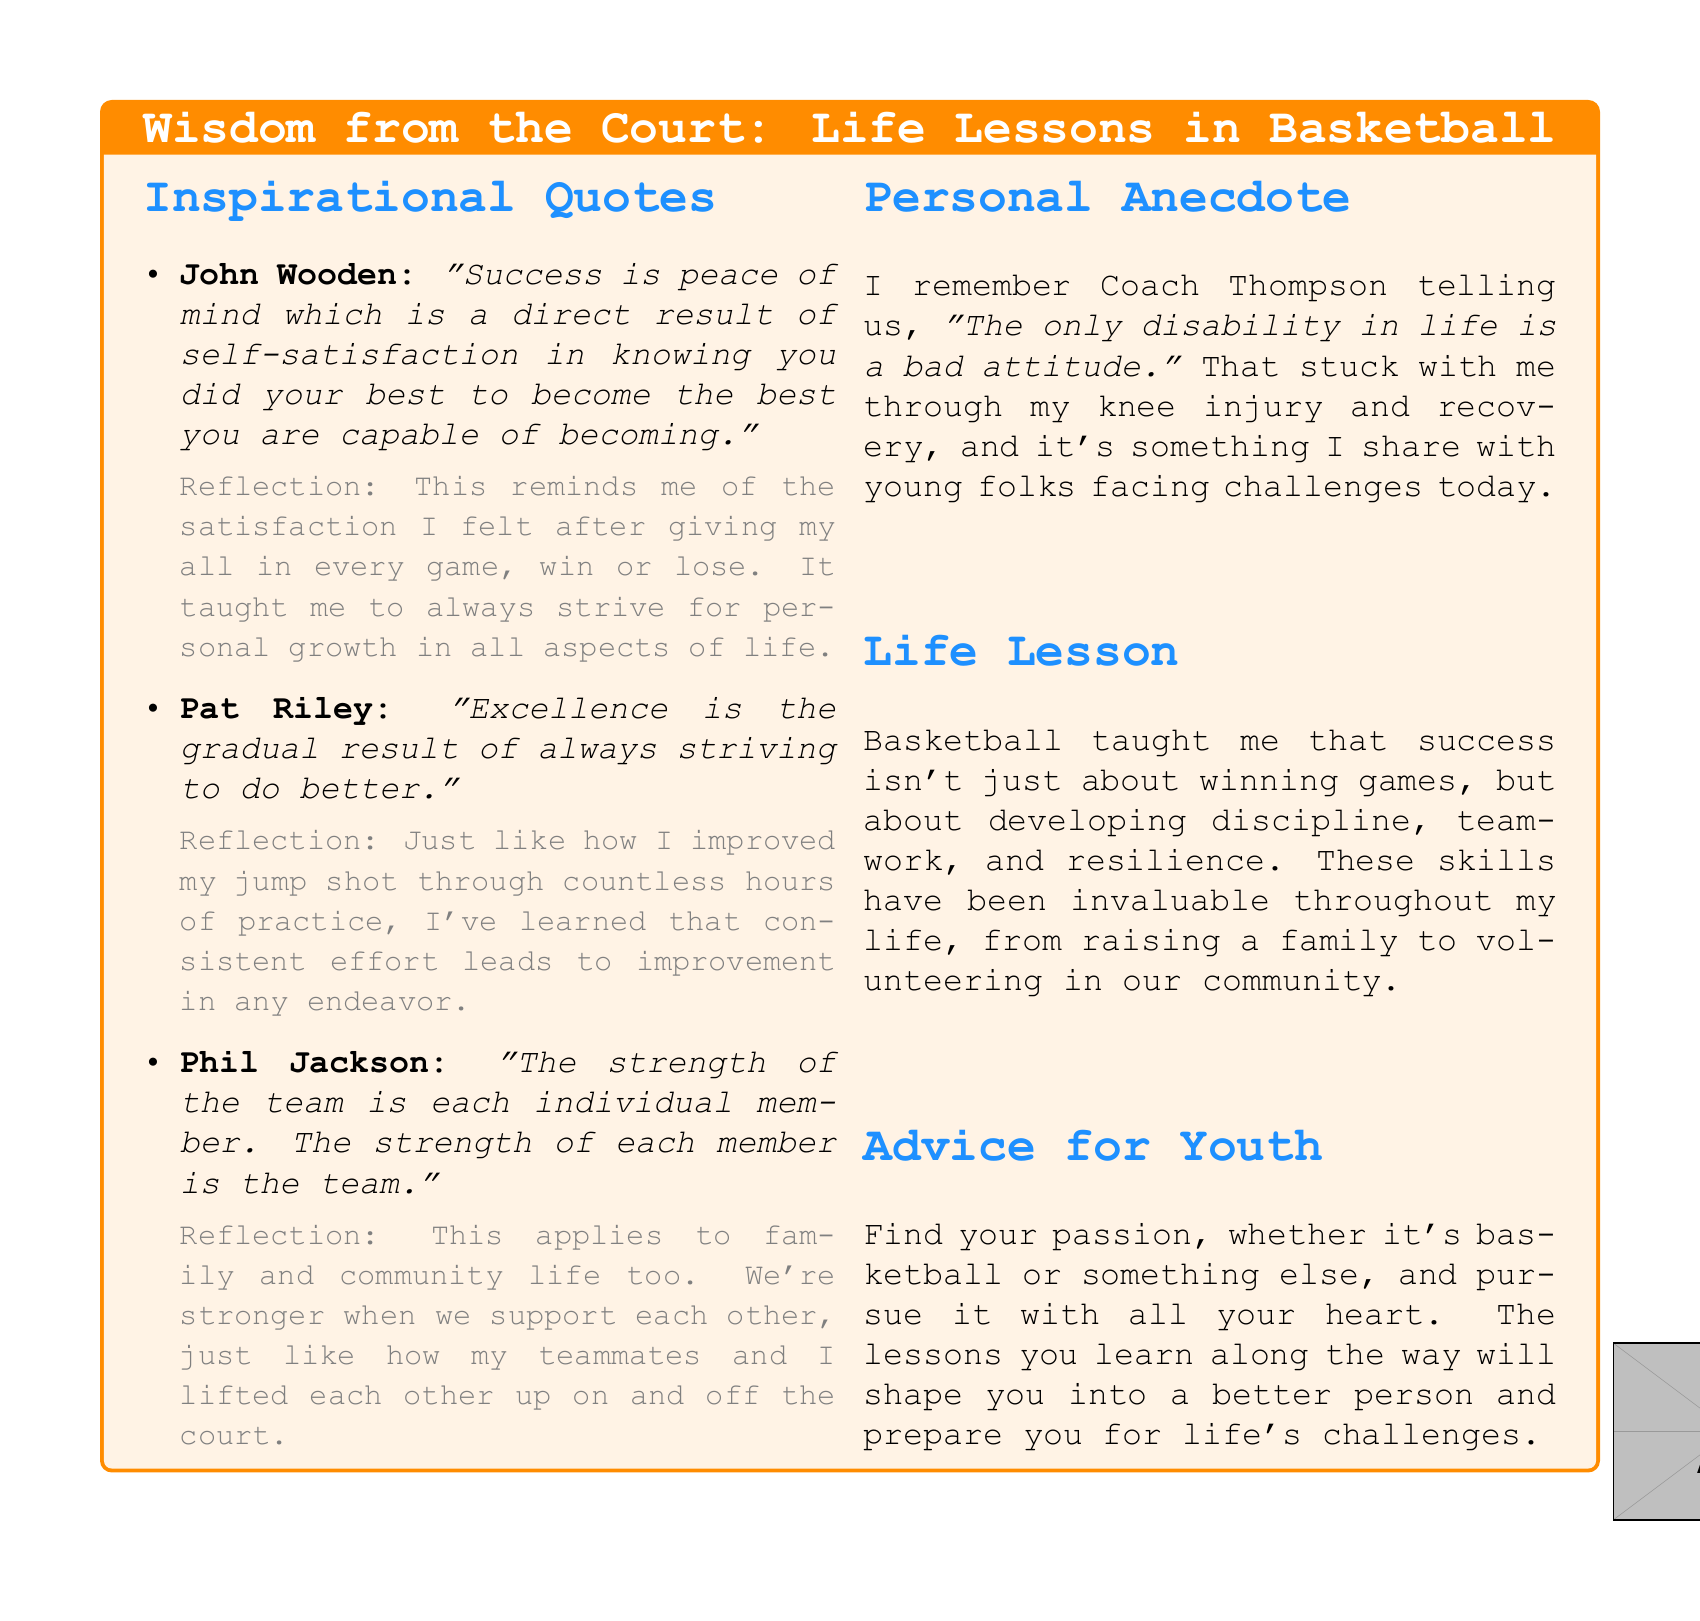What is the first quote listed in the document? The first quote is attributed to John Wooden in the list of inspirational quotes.
Answer: John Wooden: "Success is peace of mind..." What lesson does John Wooden's quote convey? John Wooden's quote focuses on self-satisfaction and personal best, which is a key theme in the reflection.
Answer: Success is peace of mind.. Who is attributed to the quote about excellence? The quote about excellence is attributed to Pat Riley, indicating the individual responsible for that insight.
Answer: Pat Riley What is a key takeaway from the personal anecdote mentioned? The personal anecdote illustrates a lesson learned during an injury recovery, emphasizing attitude.
Answer: The only disability in life is a bad attitude What is the life lesson learned from basketball according to the document? The life lesson emphasizes developing skills beyond just winning, showing the broader impact of basketball.
Answer: Success isn't just about winning games, but about developing discipline, teamwork, and resilience What advice is given for youth in the document? The advice given relates to following one's passion and the development that comes from it.
Answer: Find your passion, whether it's basketball or something else.. How does Phil Jackson's quote relate to teamwork? Phil Jackson's quote highlights the interdependence between individual strength and team strength, essential for teamwork.
Answer: The strength of the team is each individual member.. What theme is common across all the reflections on the quotes? The reflections share a common theme of personal growth and perseverance in various life aspects.
Answer: Always strive for personal growth.. Which coach's quote reflects on community life beyond basketball? Phil Jackson's quote discusses the strength of individuals and teams, applicable to community life as well.
Answer: Phil Jackson 